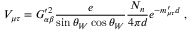<formula> <loc_0><loc_0><loc_500><loc_500>V _ { \mu \tau } = G _ { \alpha \beta } ^ { \prime 2 } \frac { e } { \sin \theta _ { W } \cos \theta _ { W } } \frac { N _ { n } } { 4 \pi d } e ^ { - m _ { \mu \tau } ^ { \prime } d } \, ,</formula> 